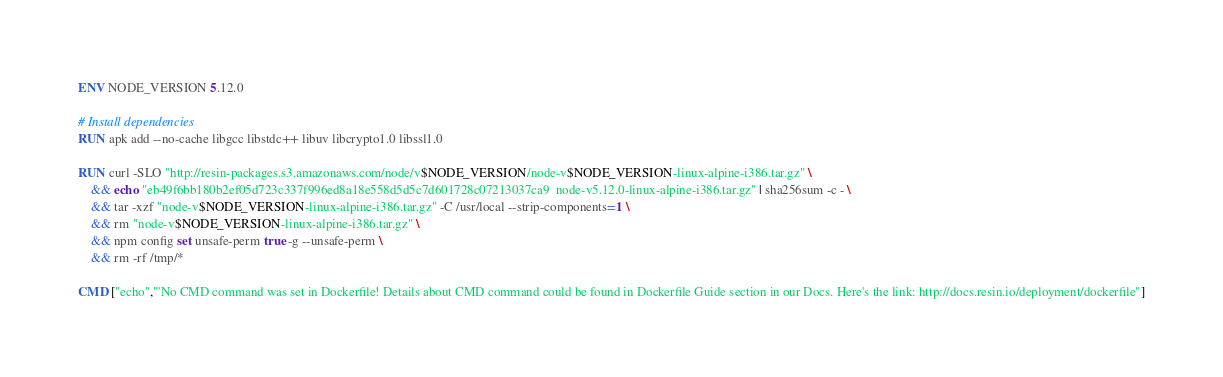Convert code to text. <code><loc_0><loc_0><loc_500><loc_500><_Dockerfile_>ENV NODE_VERSION 5.12.0

# Install dependencies
RUN apk add --no-cache libgcc libstdc++ libuv libcrypto1.0 libssl1.0

RUN curl -SLO "http://resin-packages.s3.amazonaws.com/node/v$NODE_VERSION/node-v$NODE_VERSION-linux-alpine-i386.tar.gz" \
	&& echo "eb49f6bb180b2ef05d723c337f996ed8a18e558d5d5c7d601728c07213037ca9  node-v5.12.0-linux-alpine-i386.tar.gz" | sha256sum -c - \
	&& tar -xzf "node-v$NODE_VERSION-linux-alpine-i386.tar.gz" -C /usr/local --strip-components=1 \
	&& rm "node-v$NODE_VERSION-linux-alpine-i386.tar.gz" \
	&& npm config set unsafe-perm true -g --unsafe-perm \
	&& rm -rf /tmp/*

CMD ["echo","'No CMD command was set in Dockerfile! Details about CMD command could be found in Dockerfile Guide section in our Docs. Here's the link: http://docs.resin.io/deployment/dockerfile"]
</code> 